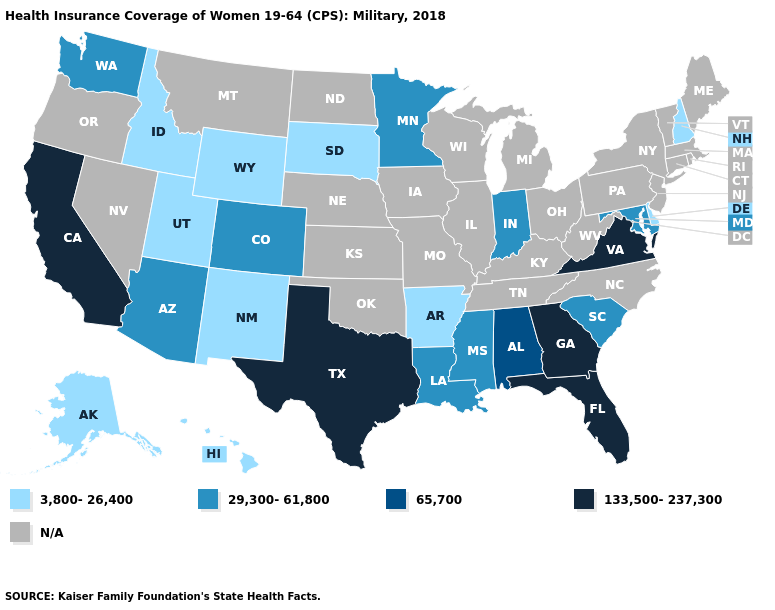What is the lowest value in the South?
Answer briefly. 3,800-26,400. What is the highest value in the South ?
Keep it brief. 133,500-237,300. What is the value of Massachusetts?
Short answer required. N/A. Is the legend a continuous bar?
Give a very brief answer. No. What is the value of New Mexico?
Write a very short answer. 3,800-26,400. Name the states that have a value in the range 3,800-26,400?
Concise answer only. Alaska, Arkansas, Delaware, Hawaii, Idaho, New Hampshire, New Mexico, South Dakota, Utah, Wyoming. What is the value of South Carolina?
Be succinct. 29,300-61,800. What is the value of New Hampshire?
Answer briefly. 3,800-26,400. Is the legend a continuous bar?
Short answer required. No. Which states have the lowest value in the South?
Quick response, please. Arkansas, Delaware. Which states have the lowest value in the Northeast?
Answer briefly. New Hampshire. Which states have the highest value in the USA?
Short answer required. California, Florida, Georgia, Texas, Virginia. What is the value of Arizona?
Short answer required. 29,300-61,800. What is the value of Delaware?
Keep it brief. 3,800-26,400. 